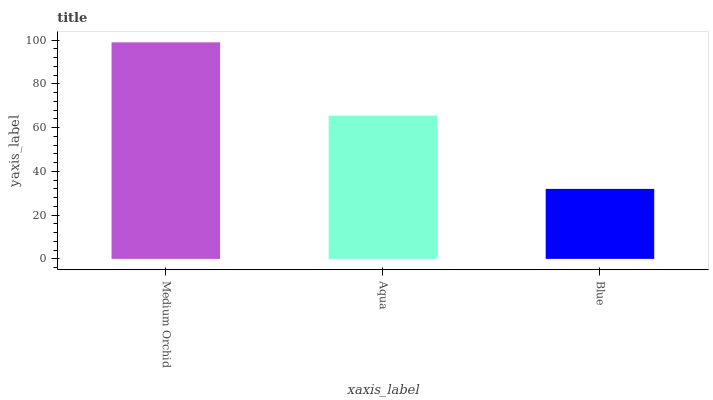Is Blue the minimum?
Answer yes or no. Yes. Is Medium Orchid the maximum?
Answer yes or no. Yes. Is Aqua the minimum?
Answer yes or no. No. Is Aqua the maximum?
Answer yes or no. No. Is Medium Orchid greater than Aqua?
Answer yes or no. Yes. Is Aqua less than Medium Orchid?
Answer yes or no. Yes. Is Aqua greater than Medium Orchid?
Answer yes or no. No. Is Medium Orchid less than Aqua?
Answer yes or no. No. Is Aqua the high median?
Answer yes or no. Yes. Is Aqua the low median?
Answer yes or no. Yes. Is Medium Orchid the high median?
Answer yes or no. No. Is Medium Orchid the low median?
Answer yes or no. No. 